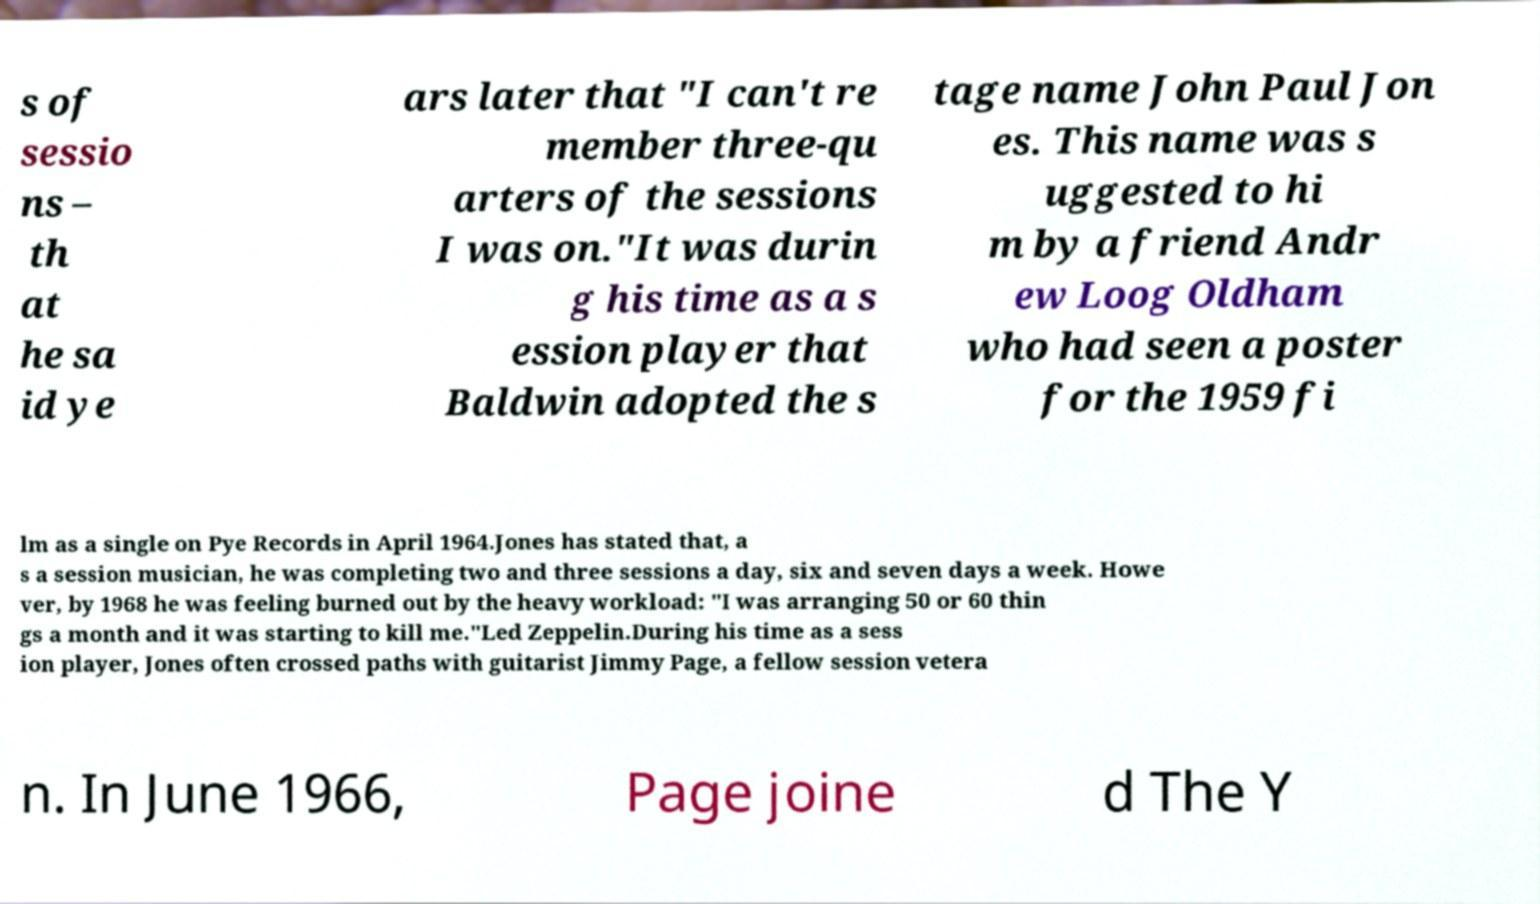Can you accurately transcribe the text from the provided image for me? s of sessio ns – th at he sa id ye ars later that "I can't re member three-qu arters of the sessions I was on."It was durin g his time as a s ession player that Baldwin adopted the s tage name John Paul Jon es. This name was s uggested to hi m by a friend Andr ew Loog Oldham who had seen a poster for the 1959 fi lm as a single on Pye Records in April 1964.Jones has stated that, a s a session musician, he was completing two and three sessions a day, six and seven days a week. Howe ver, by 1968 he was feeling burned out by the heavy workload: "I was arranging 50 or 60 thin gs a month and it was starting to kill me."Led Zeppelin.During his time as a sess ion player, Jones often crossed paths with guitarist Jimmy Page, a fellow session vetera n. In June 1966, Page joine d The Y 